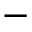<formula> <loc_0><loc_0><loc_500><loc_500>-</formula> 